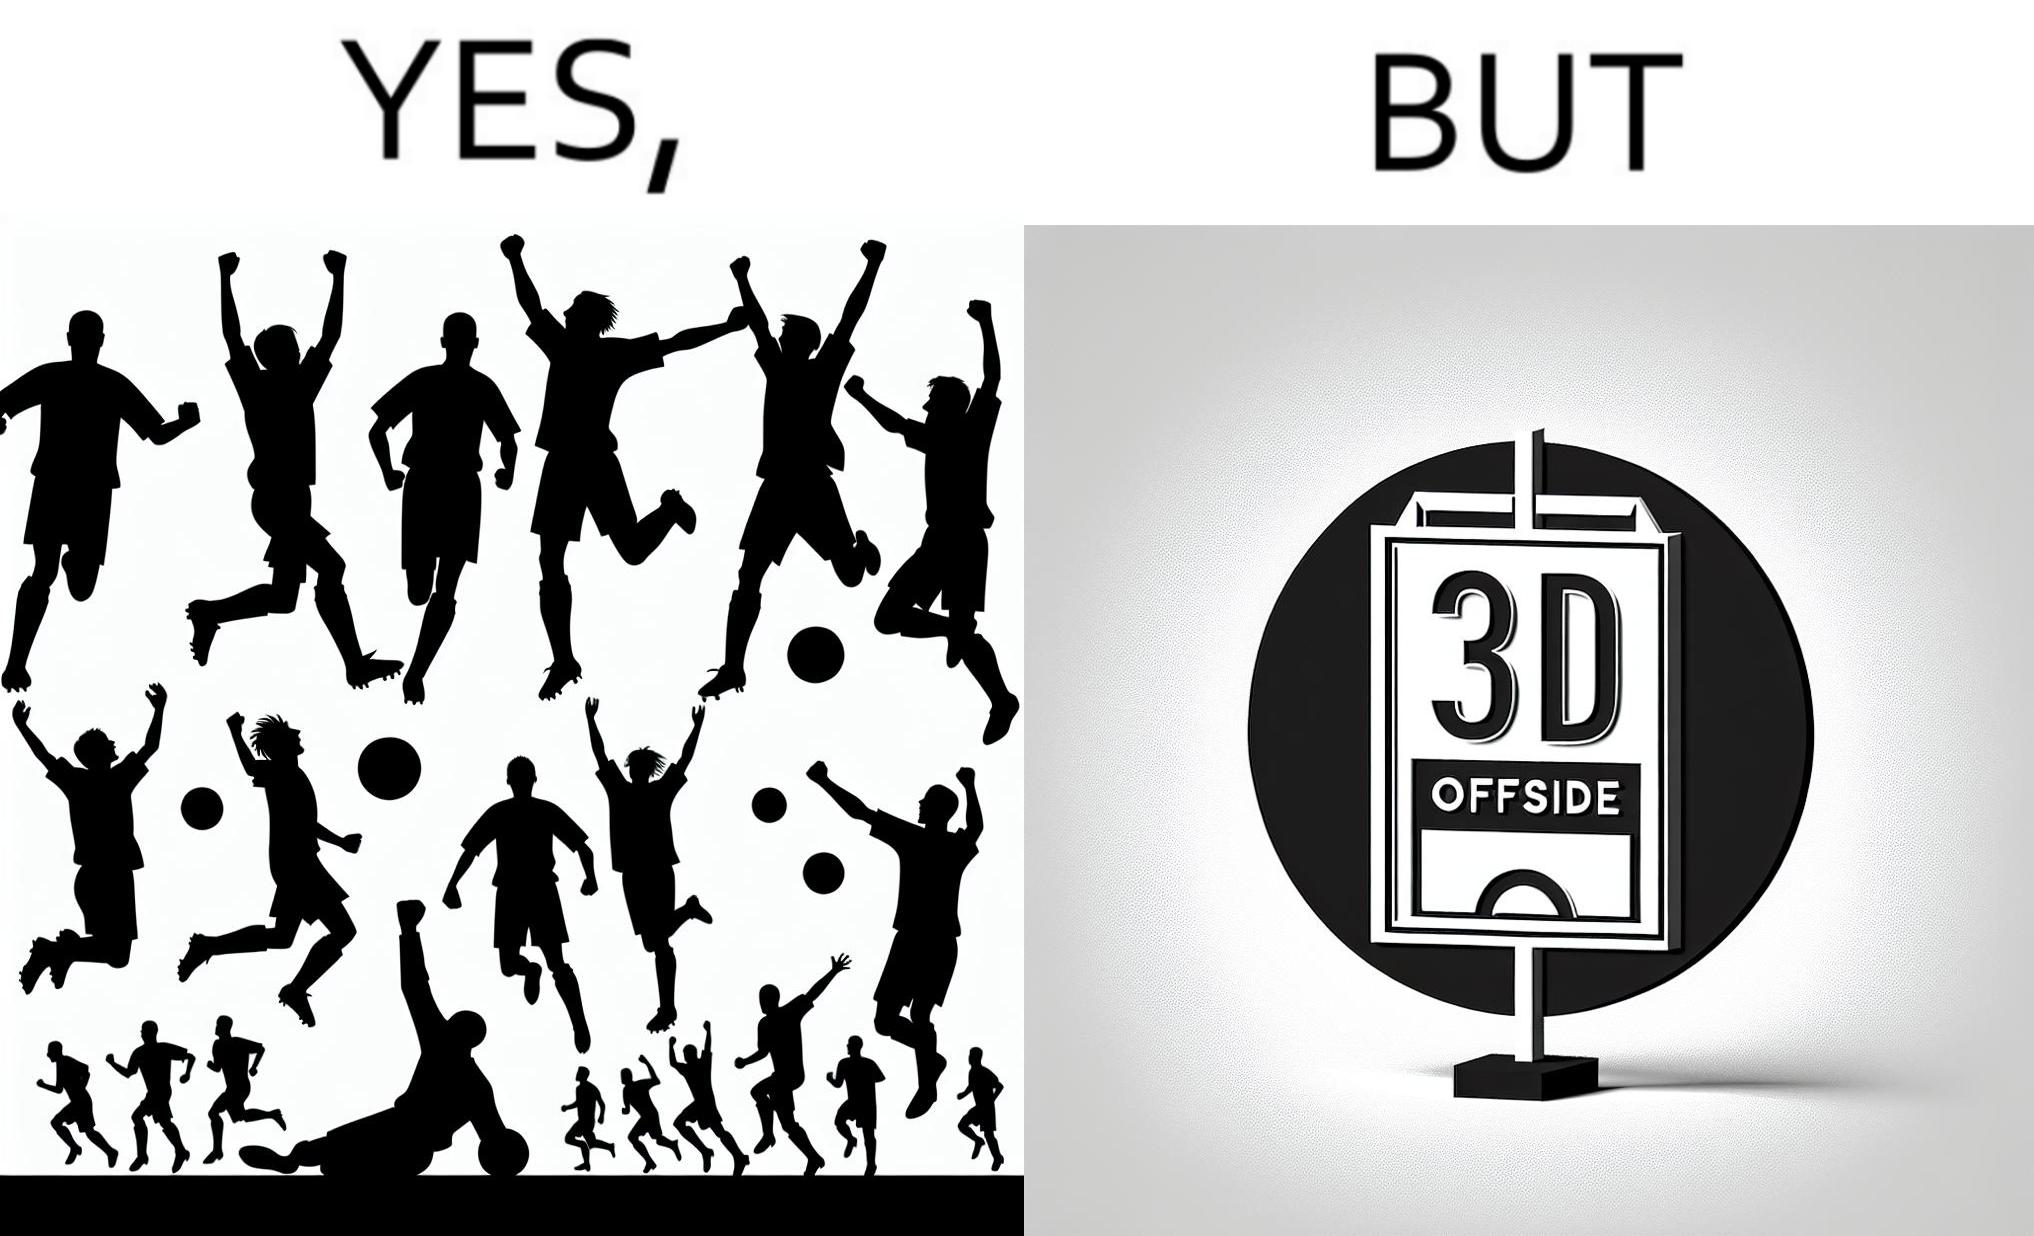What is the satirical meaning behind this image? The image is ironical, as the team is celebrating as they think that they have scored a goal, but the sign on the screen says that it is an offside, and not a goal. This is a very common scenario in football matches. 